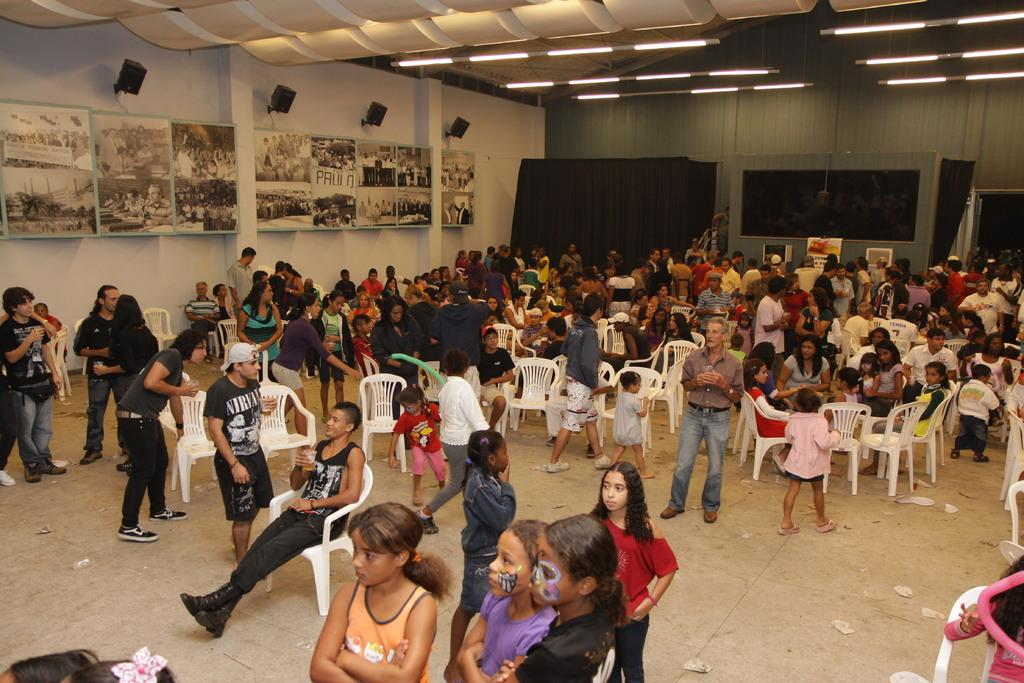How many people are in the image? There is a group of people in the image, but the exact number is not specified. What are some people doing in the image? Some people are sitting on chairs in the image. What objects can be seen in the image besides the people? There are boards, clothes, and lights visible in the image. What can be seen in the background of the image? There is a wall in the background of the image. What type of chicken is being used as a scarecrow in the image? There is no chicken or scarecrow present in the image. What material is the iron used for in the image? There is no iron or iron-related object present in the image. 